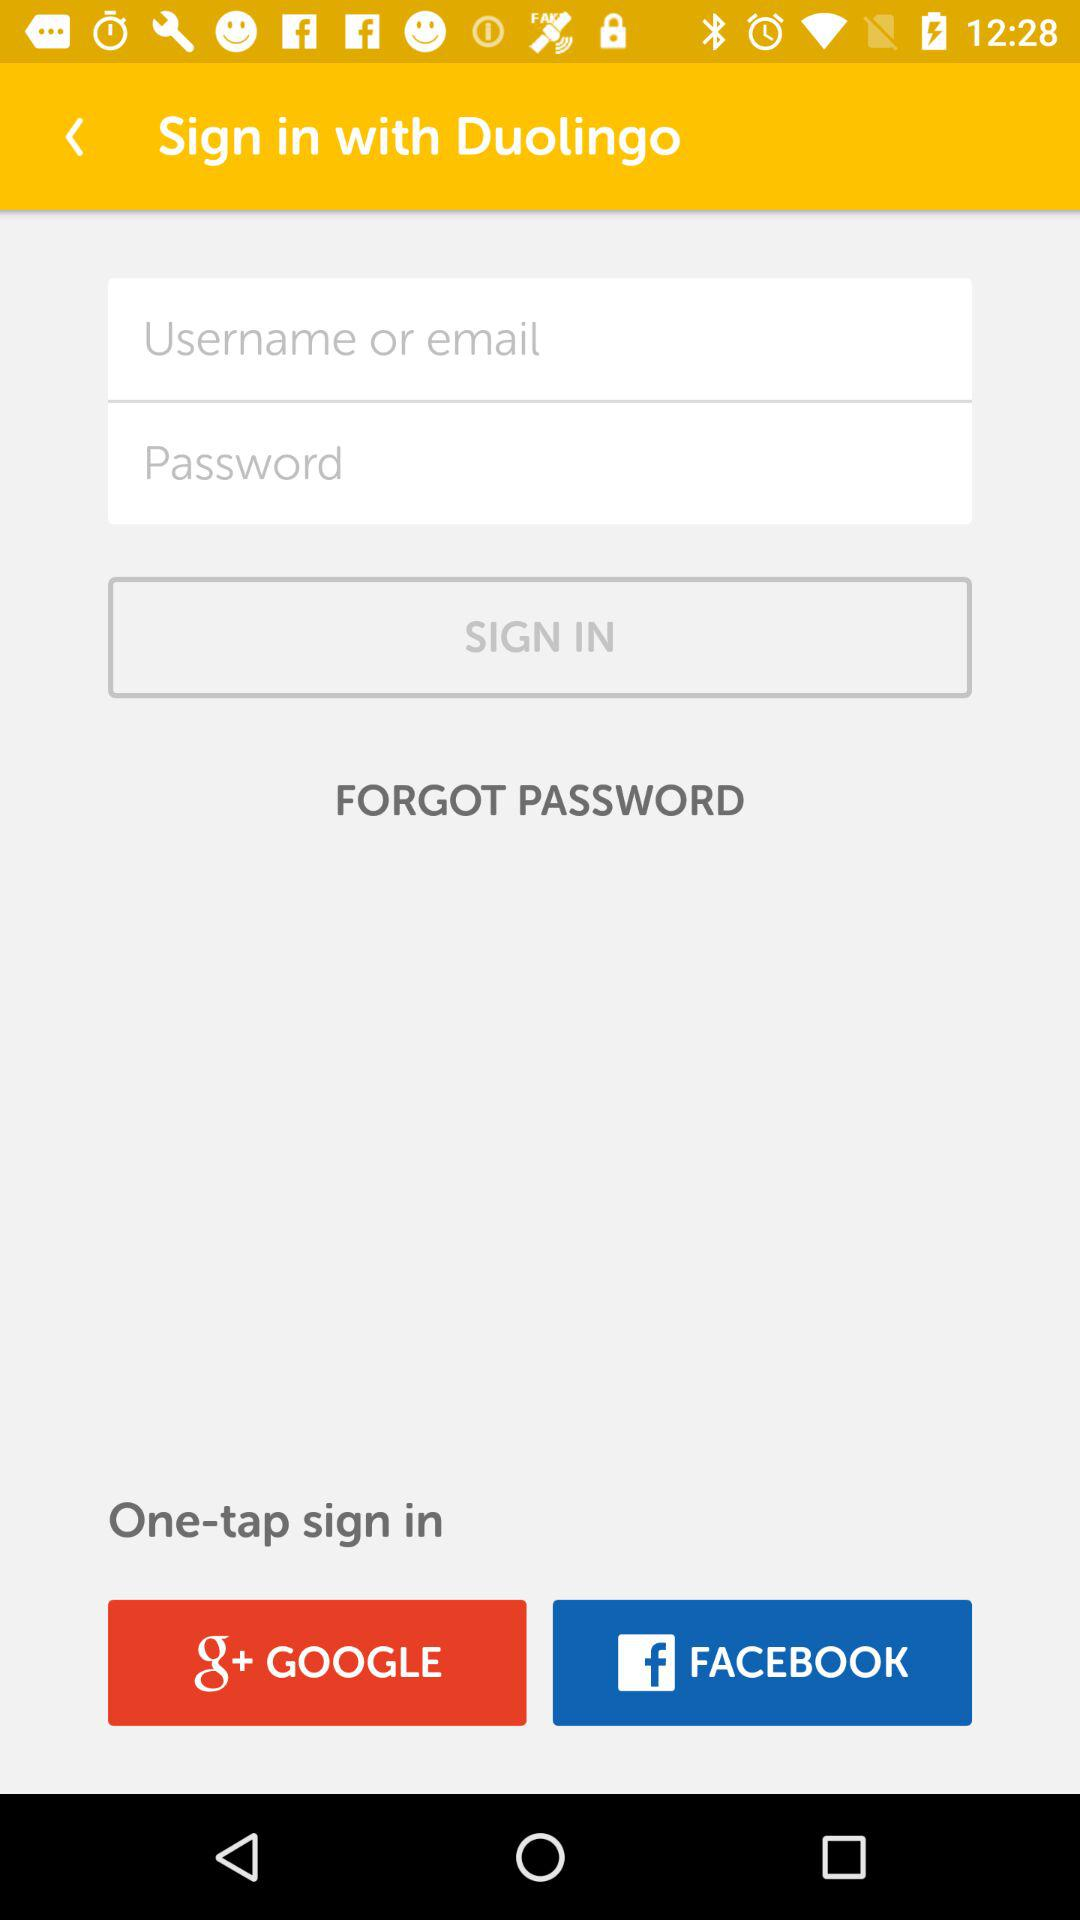How many text inputs are there for logging in?
Answer the question using a single word or phrase. 2 